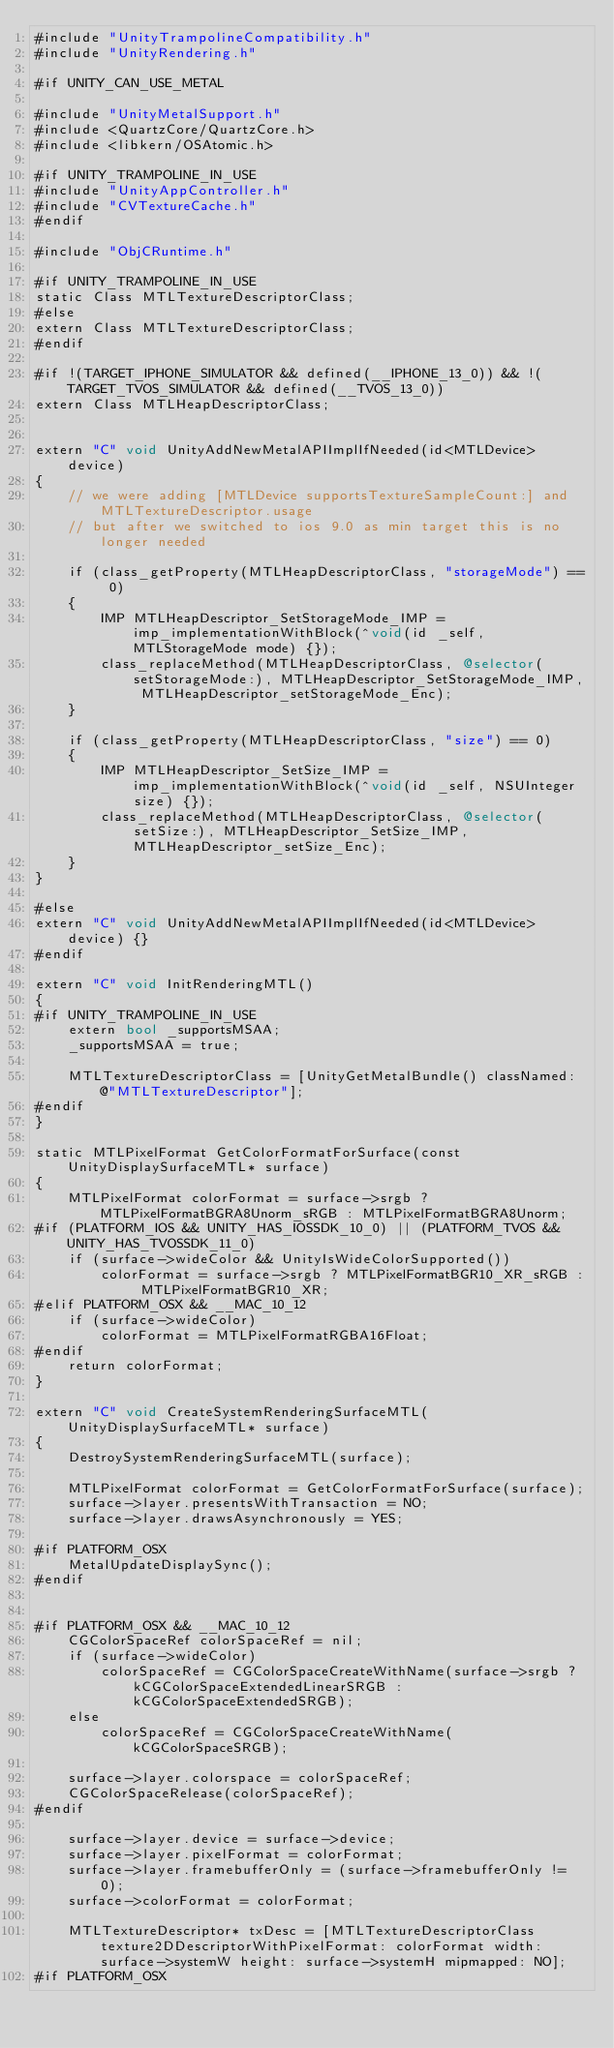Convert code to text. <code><loc_0><loc_0><loc_500><loc_500><_ObjectiveC_>#include "UnityTrampolineCompatibility.h"
#include "UnityRendering.h"

#if UNITY_CAN_USE_METAL

#include "UnityMetalSupport.h"
#include <QuartzCore/QuartzCore.h>
#include <libkern/OSAtomic.h>

#if UNITY_TRAMPOLINE_IN_USE
#include "UnityAppController.h"
#include "CVTextureCache.h"
#endif

#include "ObjCRuntime.h"

#if UNITY_TRAMPOLINE_IN_USE
static Class MTLTextureDescriptorClass;
#else
extern Class MTLTextureDescriptorClass;
#endif

#if !(TARGET_IPHONE_SIMULATOR && defined(__IPHONE_13_0)) && !(TARGET_TVOS_SIMULATOR && defined(__TVOS_13_0))
extern Class MTLHeapDescriptorClass;


extern "C" void UnityAddNewMetalAPIImplIfNeeded(id<MTLDevice> device)
{
    // we were adding [MTLDevice supportsTextureSampleCount:] and MTLTextureDescriptor.usage
    // but after we switched to ios 9.0 as min target this is no longer needed

    if (class_getProperty(MTLHeapDescriptorClass, "storageMode") == 0)
    {
        IMP MTLHeapDescriptor_SetStorageMode_IMP = imp_implementationWithBlock(^void(id _self, MTLStorageMode mode) {});
        class_replaceMethod(MTLHeapDescriptorClass, @selector(setStorageMode:), MTLHeapDescriptor_SetStorageMode_IMP, MTLHeapDescriptor_setStorageMode_Enc);
    }

    if (class_getProperty(MTLHeapDescriptorClass, "size") == 0)
    {
        IMP MTLHeapDescriptor_SetSize_IMP = imp_implementationWithBlock(^void(id _self, NSUInteger size) {});
        class_replaceMethod(MTLHeapDescriptorClass, @selector(setSize:), MTLHeapDescriptor_SetSize_IMP, MTLHeapDescriptor_setSize_Enc);
    }
}

#else
extern "C" void UnityAddNewMetalAPIImplIfNeeded(id<MTLDevice> device) {}
#endif

extern "C" void InitRenderingMTL()
{
#if UNITY_TRAMPOLINE_IN_USE
    extern bool _supportsMSAA;
    _supportsMSAA = true;

    MTLTextureDescriptorClass = [UnityGetMetalBundle() classNamed: @"MTLTextureDescriptor"];
#endif
}

static MTLPixelFormat GetColorFormatForSurface(const UnityDisplaySurfaceMTL* surface)
{
    MTLPixelFormat colorFormat = surface->srgb ? MTLPixelFormatBGRA8Unorm_sRGB : MTLPixelFormatBGRA8Unorm;
#if (PLATFORM_IOS && UNITY_HAS_IOSSDK_10_0) || (PLATFORM_TVOS && UNITY_HAS_TVOSSDK_11_0)
    if (surface->wideColor && UnityIsWideColorSupported())
        colorFormat = surface->srgb ? MTLPixelFormatBGR10_XR_sRGB : MTLPixelFormatBGR10_XR;
#elif PLATFORM_OSX && __MAC_10_12
    if (surface->wideColor)
        colorFormat = MTLPixelFormatRGBA16Float;
#endif
    return colorFormat;
}

extern "C" void CreateSystemRenderingSurfaceMTL(UnityDisplaySurfaceMTL* surface)
{
    DestroySystemRenderingSurfaceMTL(surface);

    MTLPixelFormat colorFormat = GetColorFormatForSurface(surface);
    surface->layer.presentsWithTransaction = NO;
    surface->layer.drawsAsynchronously = YES;

#if PLATFORM_OSX
    MetalUpdateDisplaySync();
#endif


#if PLATFORM_OSX && __MAC_10_12
    CGColorSpaceRef colorSpaceRef = nil;
    if (surface->wideColor)
        colorSpaceRef = CGColorSpaceCreateWithName(surface->srgb ? kCGColorSpaceExtendedLinearSRGB : kCGColorSpaceExtendedSRGB);
    else
        colorSpaceRef = CGColorSpaceCreateWithName(kCGColorSpaceSRGB);

    surface->layer.colorspace = colorSpaceRef;
    CGColorSpaceRelease(colorSpaceRef);
#endif

    surface->layer.device = surface->device;
    surface->layer.pixelFormat = colorFormat;
    surface->layer.framebufferOnly = (surface->framebufferOnly != 0);
    surface->colorFormat = colorFormat;

    MTLTextureDescriptor* txDesc = [MTLTextureDescriptorClass texture2DDescriptorWithPixelFormat: colorFormat width: surface->systemW height: surface->systemH mipmapped: NO];
#if PLATFORM_OSX</code> 